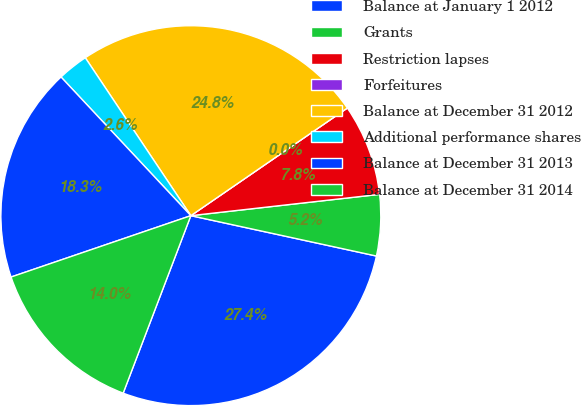Convert chart to OTSL. <chart><loc_0><loc_0><loc_500><loc_500><pie_chart><fcel>Balance at January 1 2012<fcel>Grants<fcel>Restriction lapses<fcel>Forfeitures<fcel>Balance at December 31 2012<fcel>Additional performance shares<fcel>Balance at December 31 2013<fcel>Balance at December 31 2014<nl><fcel>27.39%<fcel>5.2%<fcel>7.8%<fcel>0.0%<fcel>24.79%<fcel>2.6%<fcel>18.26%<fcel>13.97%<nl></chart> 